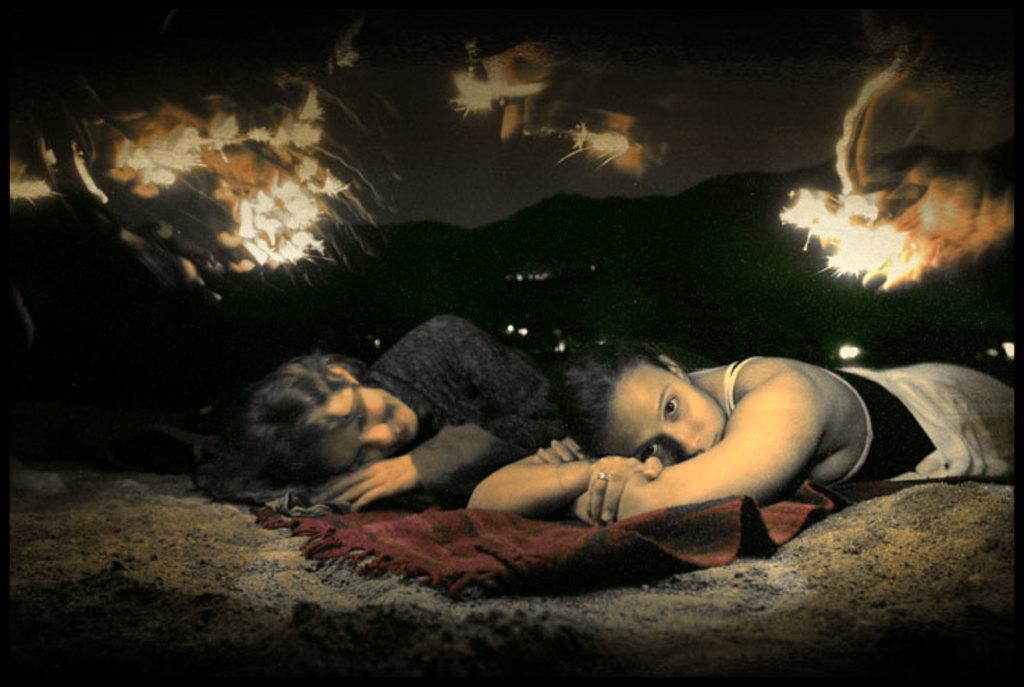How would you summarize this image in a sentence or two? In this image we can see two ladies sleeping on the floor. There is a red color carpet. In the background of the image there are mountains. This is an edited image. 